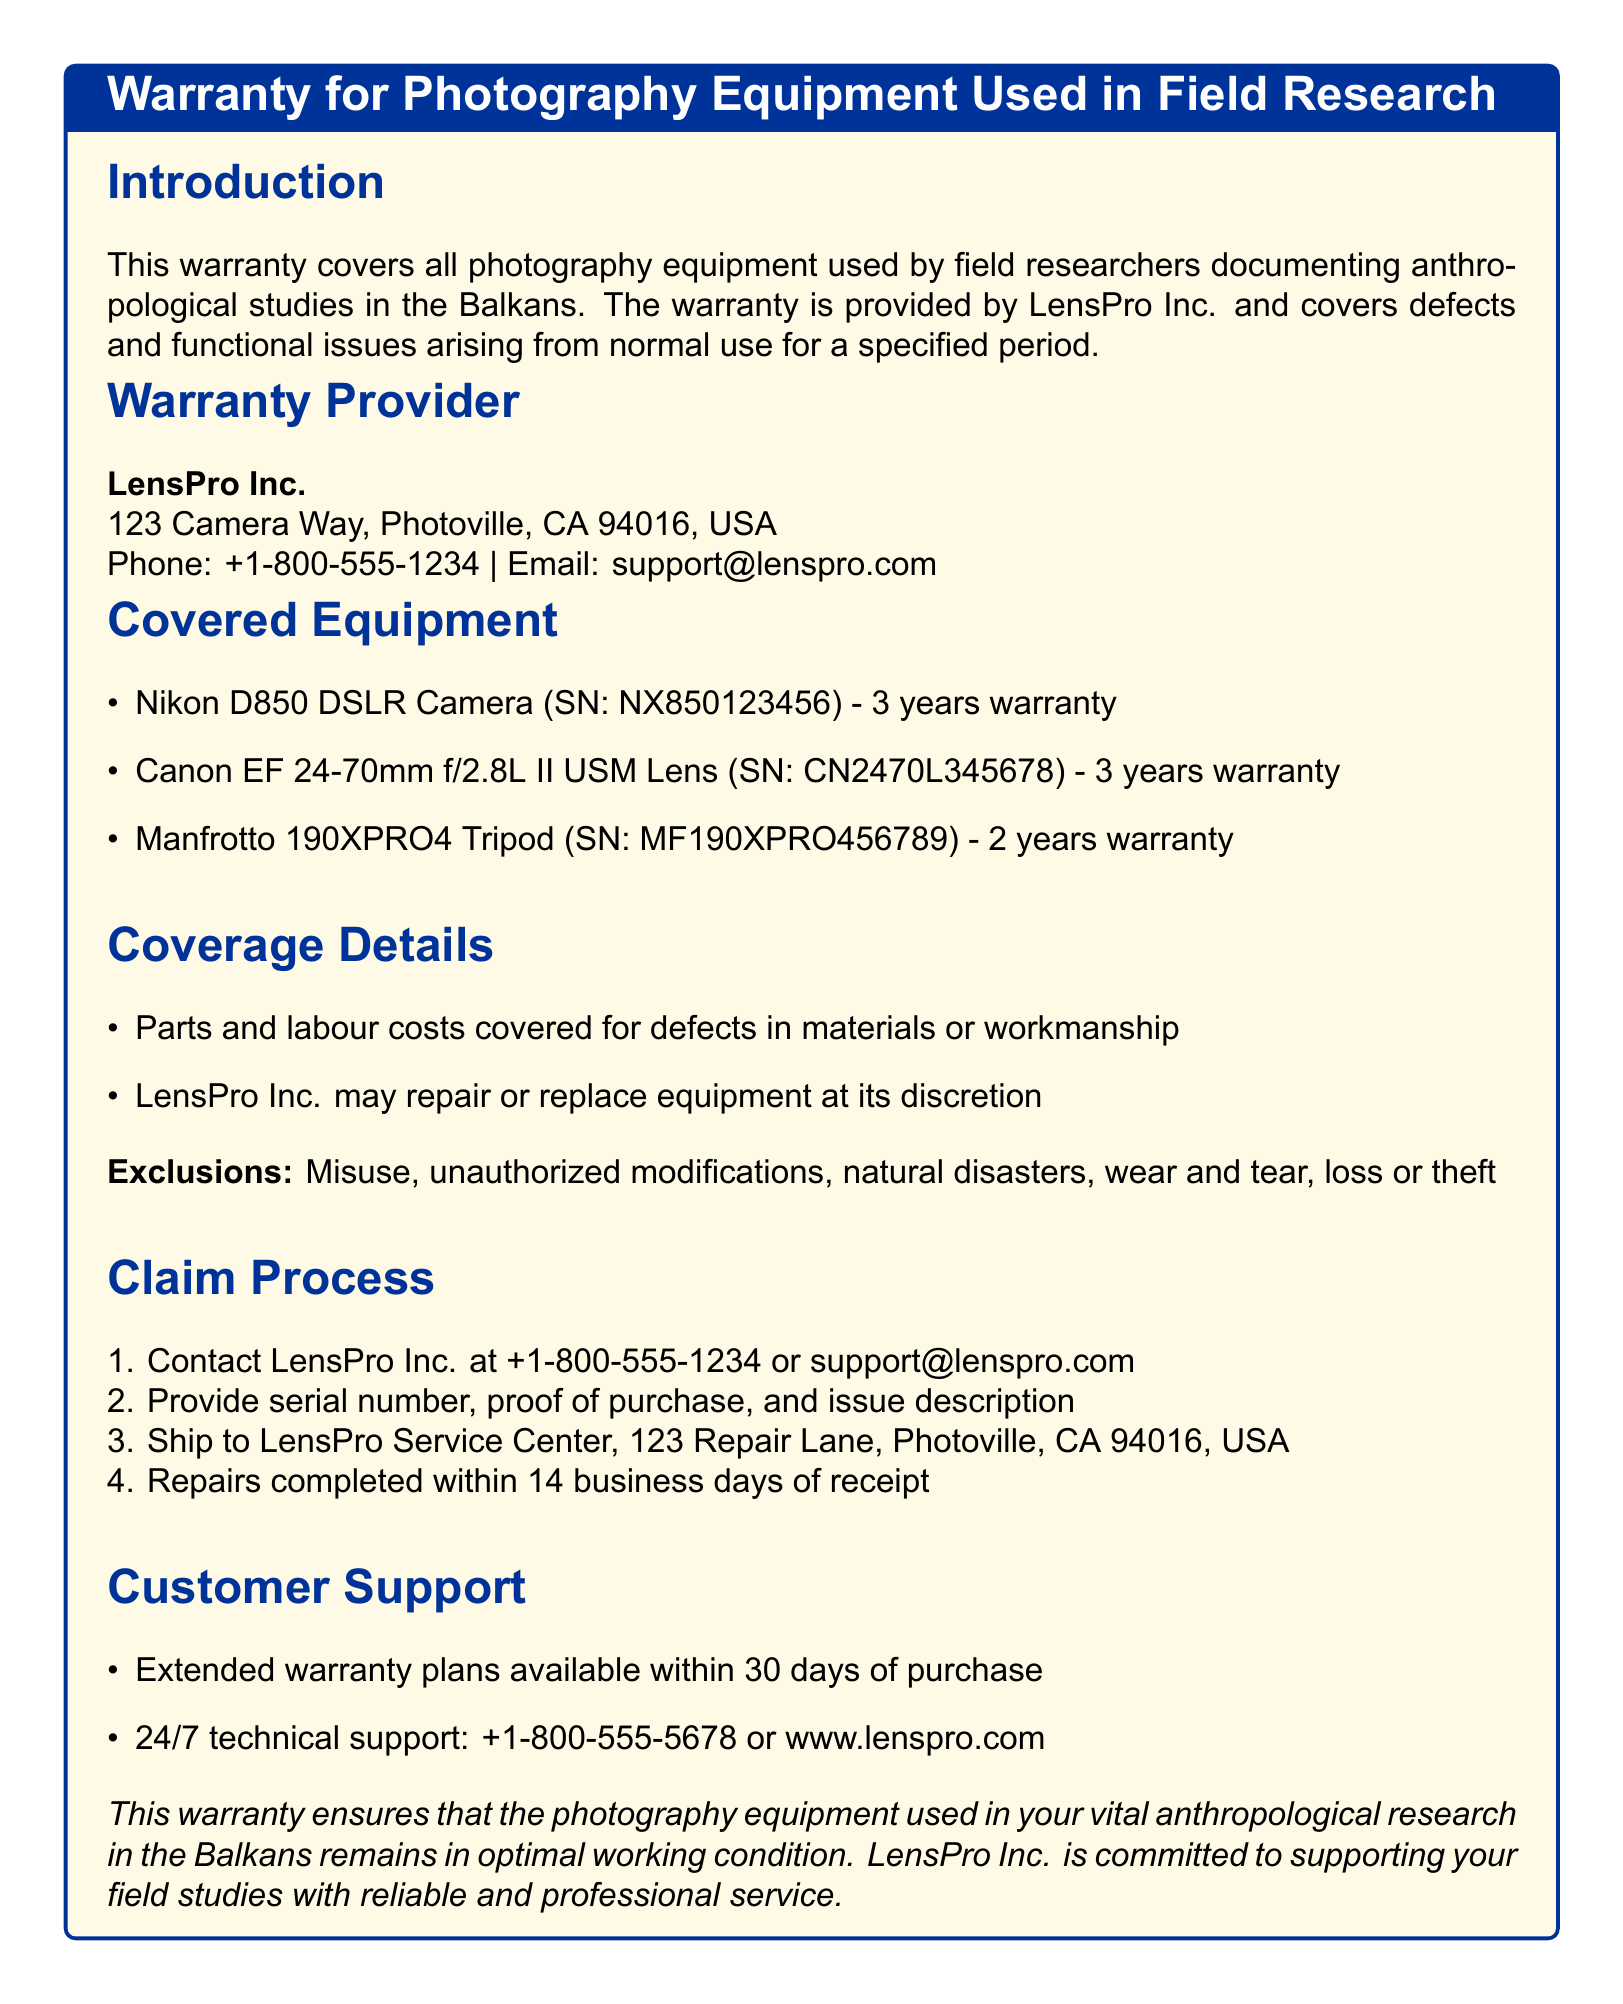What is the name of the warranty provider? The warranty provider is mentioned in the document as LensPro Inc.
Answer: LensPro Inc What is the warranty period for the Nikon D850 DSLR Camera? The warranty period for the Nikon D850 DSLR Camera as specified is 3 years.
Answer: 3 years What is covered under the warranty? The coverage details mention that parts and labour costs for defects in materials or workmanship are covered.
Answer: Defects in materials or workmanship What is NOT covered under the warranty? The document lists exclusions, including misuse and natural disasters, which are not covered by the warranty.
Answer: Misuse What is the contact number for customer support? The document provides a specific customer support contact number.
Answer: +1-800-555-5678 How long does the repair process take? The claim process indicates that repairs are completed within a specific time frame of receipt.
Answer: 14 business days What is required to initiate a warranty claim? The claim process describes the necessary steps to start a claim, including providing a proof of purchase.
Answer: Proof of purchase What type of support is available 24/7? The document states technical support is available around the clock.
Answer: Technical support What is the warranty duration for the Manfrotto tripod? The warranty duration for the Manfrotto 190XPRO4 Tripod is explicitly mentioned.
Answer: 2 years 